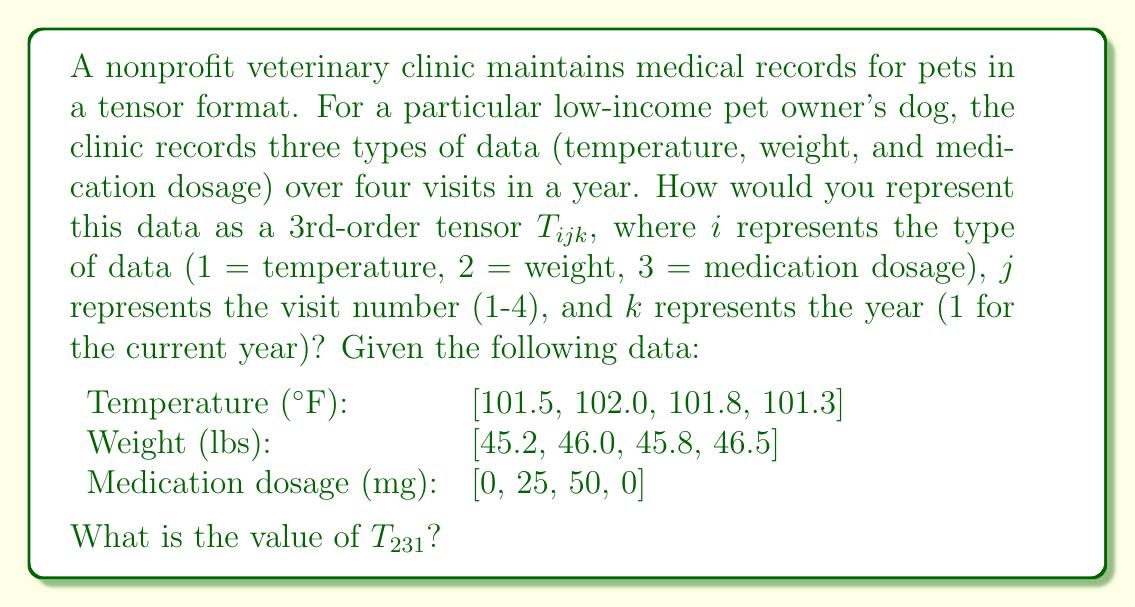Provide a solution to this math problem. To solve this problem, we need to follow these steps:

1) First, let's understand the structure of the tensor $T_{ijk}$:
   - $i$ represents the type of data (1 = temperature, 2 = weight, 3 = medication dosage)
   - $j$ represents the visit number (1-4)
   - $k$ represents the year (1 for the current year)

2) We can visualize this as a 3 x 4 x 1 tensor, where:
   - The first dimension (3) represents the three types of data
   - The second dimension (4) represents the four visits
   - The third dimension (1) represents the single year of data

3) Let's fill in the tensor:

   $$T_{ijk} = \begin{bmatrix}
   [101.5 & 102.0 & 101.8 & 101.3] \\
   [45.2 & 46.0 & 45.8 & 46.5] \\
   [0 & 25 & 50 & 0]
   \end{bmatrix}$$

4) Now, we need to find $T_{231}$. In this notation:
   - 2 refers to the second type of data (weight)
   - 3 refers to the third visit
   - 1 refers to the first (and only) year

5) Looking at our tensor, we can see that $T_{231}$ corresponds to the weight at the third visit, which is 45.8 lbs.

Therefore, $T_{231} = 45.8$.
Answer: $T_{231} = 45.8$ 